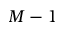<formula> <loc_0><loc_0><loc_500><loc_500>M - 1</formula> 